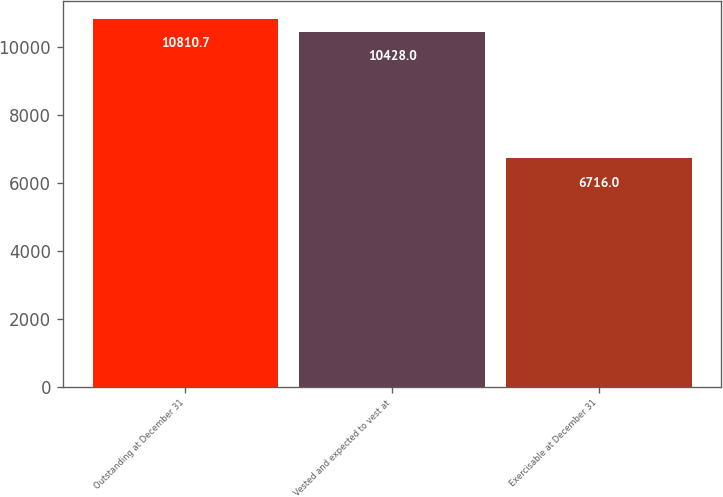<chart> <loc_0><loc_0><loc_500><loc_500><bar_chart><fcel>Outstanding at December 31<fcel>Vested and expected to vest at<fcel>Exercisable at December 31<nl><fcel>10810.7<fcel>10428<fcel>6716<nl></chart> 